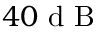Convert formula to latex. <formula><loc_0><loc_0><loc_500><loc_500>4 0 d B</formula> 